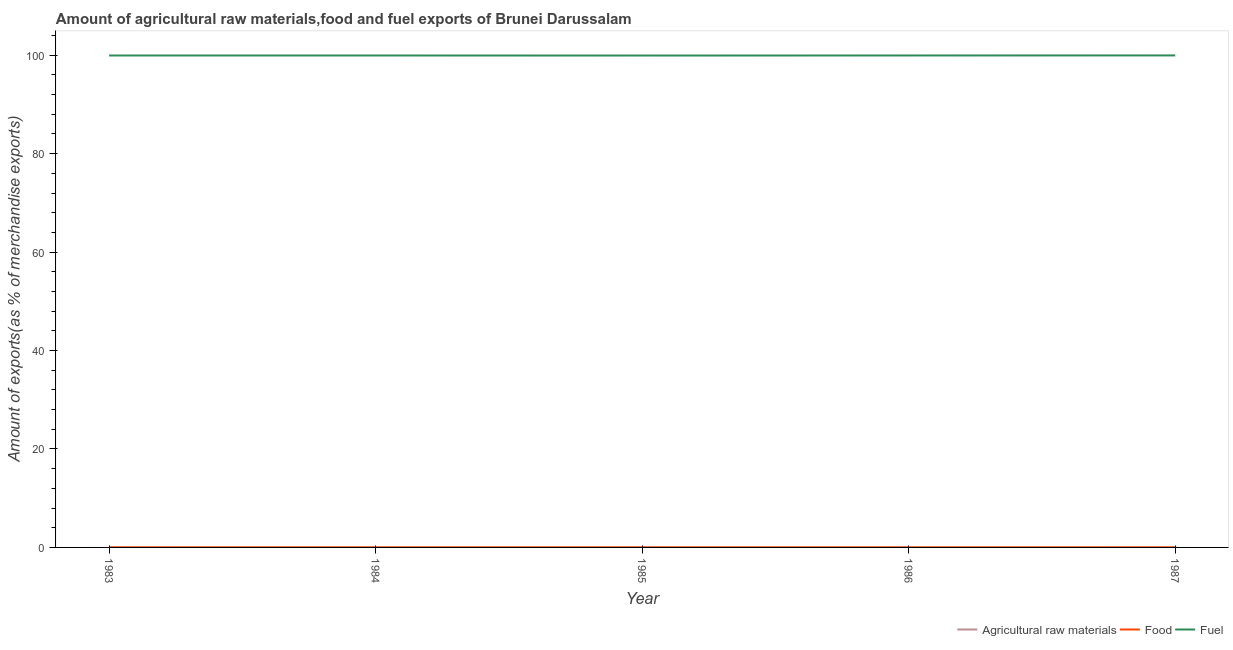How many different coloured lines are there?
Ensure brevity in your answer.  3. What is the percentage of fuel exports in 1985?
Your answer should be very brief. 99.93. Across all years, what is the maximum percentage of fuel exports?
Your response must be concise. 99.95. Across all years, what is the minimum percentage of raw materials exports?
Your answer should be compact. 0. In which year was the percentage of food exports minimum?
Offer a very short reply. 1987. What is the total percentage of raw materials exports in the graph?
Give a very brief answer. 0.01. What is the difference between the percentage of raw materials exports in 1984 and that in 1985?
Provide a succinct answer. -0. What is the difference between the percentage of fuel exports in 1983 and the percentage of food exports in 1987?
Make the answer very short. 99.94. What is the average percentage of food exports per year?
Provide a succinct answer. 0.01. In the year 1987, what is the difference between the percentage of raw materials exports and percentage of fuel exports?
Make the answer very short. -99.95. What is the ratio of the percentage of food exports in 1983 to that in 1984?
Your answer should be very brief. 0.78. What is the difference between the highest and the second highest percentage of food exports?
Your answer should be very brief. 0. What is the difference between the highest and the lowest percentage of raw materials exports?
Make the answer very short. 0.01. Does the percentage of raw materials exports monotonically increase over the years?
Offer a very short reply. No. What is the difference between two consecutive major ticks on the Y-axis?
Offer a very short reply. 20. Are the values on the major ticks of Y-axis written in scientific E-notation?
Make the answer very short. No. Does the graph contain grids?
Your response must be concise. No. What is the title of the graph?
Keep it short and to the point. Amount of agricultural raw materials,food and fuel exports of Brunei Darussalam. What is the label or title of the Y-axis?
Ensure brevity in your answer.  Amount of exports(as % of merchandise exports). What is the Amount of exports(as % of merchandise exports) in Agricultural raw materials in 1983?
Make the answer very short. 0. What is the Amount of exports(as % of merchandise exports) in Food in 1983?
Give a very brief answer. 0.01. What is the Amount of exports(as % of merchandise exports) of Fuel in 1983?
Your response must be concise. 99.94. What is the Amount of exports(as % of merchandise exports) in Agricultural raw materials in 1984?
Provide a short and direct response. 0. What is the Amount of exports(as % of merchandise exports) of Food in 1984?
Your response must be concise. 0.01. What is the Amount of exports(as % of merchandise exports) in Fuel in 1984?
Provide a succinct answer. 99.94. What is the Amount of exports(as % of merchandise exports) of Agricultural raw materials in 1985?
Your answer should be compact. 0. What is the Amount of exports(as % of merchandise exports) of Food in 1985?
Ensure brevity in your answer.  0.01. What is the Amount of exports(as % of merchandise exports) in Fuel in 1985?
Keep it short and to the point. 99.93. What is the Amount of exports(as % of merchandise exports) in Agricultural raw materials in 1986?
Provide a short and direct response. 0. What is the Amount of exports(as % of merchandise exports) in Food in 1986?
Keep it short and to the point. 0.01. What is the Amount of exports(as % of merchandise exports) of Fuel in 1986?
Give a very brief answer. 99.95. What is the Amount of exports(as % of merchandise exports) in Agricultural raw materials in 1987?
Give a very brief answer. 0.01. What is the Amount of exports(as % of merchandise exports) in Food in 1987?
Offer a terse response. 0. What is the Amount of exports(as % of merchandise exports) of Fuel in 1987?
Make the answer very short. 99.95. Across all years, what is the maximum Amount of exports(as % of merchandise exports) of Agricultural raw materials?
Offer a very short reply. 0.01. Across all years, what is the maximum Amount of exports(as % of merchandise exports) of Food?
Your answer should be very brief. 0.01. Across all years, what is the maximum Amount of exports(as % of merchandise exports) of Fuel?
Ensure brevity in your answer.  99.95. Across all years, what is the minimum Amount of exports(as % of merchandise exports) in Agricultural raw materials?
Ensure brevity in your answer.  0. Across all years, what is the minimum Amount of exports(as % of merchandise exports) in Food?
Ensure brevity in your answer.  0. Across all years, what is the minimum Amount of exports(as % of merchandise exports) in Fuel?
Keep it short and to the point. 99.93. What is the total Amount of exports(as % of merchandise exports) of Agricultural raw materials in the graph?
Your answer should be compact. 0.01. What is the total Amount of exports(as % of merchandise exports) in Food in the graph?
Your response must be concise. 0.03. What is the total Amount of exports(as % of merchandise exports) of Fuel in the graph?
Make the answer very short. 499.72. What is the difference between the Amount of exports(as % of merchandise exports) of Agricultural raw materials in 1983 and that in 1984?
Keep it short and to the point. 0. What is the difference between the Amount of exports(as % of merchandise exports) in Food in 1983 and that in 1984?
Give a very brief answer. -0. What is the difference between the Amount of exports(as % of merchandise exports) of Agricultural raw materials in 1983 and that in 1985?
Provide a short and direct response. 0. What is the difference between the Amount of exports(as % of merchandise exports) in Food in 1983 and that in 1985?
Offer a terse response. -0. What is the difference between the Amount of exports(as % of merchandise exports) in Fuel in 1983 and that in 1985?
Ensure brevity in your answer.  0.01. What is the difference between the Amount of exports(as % of merchandise exports) of Agricultural raw materials in 1983 and that in 1986?
Your answer should be compact. 0. What is the difference between the Amount of exports(as % of merchandise exports) in Food in 1983 and that in 1986?
Your response must be concise. -0. What is the difference between the Amount of exports(as % of merchandise exports) of Fuel in 1983 and that in 1986?
Ensure brevity in your answer.  -0. What is the difference between the Amount of exports(as % of merchandise exports) in Agricultural raw materials in 1983 and that in 1987?
Give a very brief answer. -0. What is the difference between the Amount of exports(as % of merchandise exports) of Food in 1983 and that in 1987?
Provide a succinct answer. 0. What is the difference between the Amount of exports(as % of merchandise exports) of Fuel in 1983 and that in 1987?
Provide a succinct answer. -0.01. What is the difference between the Amount of exports(as % of merchandise exports) in Agricultural raw materials in 1984 and that in 1985?
Your answer should be very brief. -0. What is the difference between the Amount of exports(as % of merchandise exports) of Food in 1984 and that in 1985?
Provide a short and direct response. 0. What is the difference between the Amount of exports(as % of merchandise exports) in Fuel in 1984 and that in 1985?
Ensure brevity in your answer.  0.01. What is the difference between the Amount of exports(as % of merchandise exports) of Agricultural raw materials in 1984 and that in 1986?
Give a very brief answer. -0. What is the difference between the Amount of exports(as % of merchandise exports) in Food in 1984 and that in 1986?
Your answer should be very brief. 0. What is the difference between the Amount of exports(as % of merchandise exports) in Fuel in 1984 and that in 1986?
Your answer should be very brief. -0. What is the difference between the Amount of exports(as % of merchandise exports) of Agricultural raw materials in 1984 and that in 1987?
Provide a short and direct response. -0.01. What is the difference between the Amount of exports(as % of merchandise exports) of Food in 1984 and that in 1987?
Your response must be concise. 0. What is the difference between the Amount of exports(as % of merchandise exports) of Fuel in 1984 and that in 1987?
Offer a very short reply. -0.01. What is the difference between the Amount of exports(as % of merchandise exports) of Fuel in 1985 and that in 1986?
Provide a succinct answer. -0.01. What is the difference between the Amount of exports(as % of merchandise exports) of Agricultural raw materials in 1985 and that in 1987?
Provide a short and direct response. -0.01. What is the difference between the Amount of exports(as % of merchandise exports) of Food in 1985 and that in 1987?
Your answer should be very brief. 0. What is the difference between the Amount of exports(as % of merchandise exports) of Fuel in 1985 and that in 1987?
Give a very brief answer. -0.02. What is the difference between the Amount of exports(as % of merchandise exports) of Agricultural raw materials in 1986 and that in 1987?
Your answer should be very brief. -0.01. What is the difference between the Amount of exports(as % of merchandise exports) in Food in 1986 and that in 1987?
Keep it short and to the point. 0. What is the difference between the Amount of exports(as % of merchandise exports) in Fuel in 1986 and that in 1987?
Your answer should be very brief. -0.01. What is the difference between the Amount of exports(as % of merchandise exports) of Agricultural raw materials in 1983 and the Amount of exports(as % of merchandise exports) of Food in 1984?
Offer a very short reply. -0. What is the difference between the Amount of exports(as % of merchandise exports) in Agricultural raw materials in 1983 and the Amount of exports(as % of merchandise exports) in Fuel in 1984?
Provide a short and direct response. -99.94. What is the difference between the Amount of exports(as % of merchandise exports) of Food in 1983 and the Amount of exports(as % of merchandise exports) of Fuel in 1984?
Your response must be concise. -99.94. What is the difference between the Amount of exports(as % of merchandise exports) in Agricultural raw materials in 1983 and the Amount of exports(as % of merchandise exports) in Food in 1985?
Provide a short and direct response. -0. What is the difference between the Amount of exports(as % of merchandise exports) of Agricultural raw materials in 1983 and the Amount of exports(as % of merchandise exports) of Fuel in 1985?
Your response must be concise. -99.93. What is the difference between the Amount of exports(as % of merchandise exports) of Food in 1983 and the Amount of exports(as % of merchandise exports) of Fuel in 1985?
Provide a succinct answer. -99.93. What is the difference between the Amount of exports(as % of merchandise exports) of Agricultural raw materials in 1983 and the Amount of exports(as % of merchandise exports) of Food in 1986?
Give a very brief answer. -0. What is the difference between the Amount of exports(as % of merchandise exports) in Agricultural raw materials in 1983 and the Amount of exports(as % of merchandise exports) in Fuel in 1986?
Offer a terse response. -99.94. What is the difference between the Amount of exports(as % of merchandise exports) in Food in 1983 and the Amount of exports(as % of merchandise exports) in Fuel in 1986?
Give a very brief answer. -99.94. What is the difference between the Amount of exports(as % of merchandise exports) in Agricultural raw materials in 1983 and the Amount of exports(as % of merchandise exports) in Food in 1987?
Your answer should be very brief. 0. What is the difference between the Amount of exports(as % of merchandise exports) in Agricultural raw materials in 1983 and the Amount of exports(as % of merchandise exports) in Fuel in 1987?
Give a very brief answer. -99.95. What is the difference between the Amount of exports(as % of merchandise exports) of Food in 1983 and the Amount of exports(as % of merchandise exports) of Fuel in 1987?
Offer a very short reply. -99.95. What is the difference between the Amount of exports(as % of merchandise exports) of Agricultural raw materials in 1984 and the Amount of exports(as % of merchandise exports) of Food in 1985?
Keep it short and to the point. -0.01. What is the difference between the Amount of exports(as % of merchandise exports) in Agricultural raw materials in 1984 and the Amount of exports(as % of merchandise exports) in Fuel in 1985?
Your answer should be compact. -99.93. What is the difference between the Amount of exports(as % of merchandise exports) in Food in 1984 and the Amount of exports(as % of merchandise exports) in Fuel in 1985?
Your answer should be very brief. -99.93. What is the difference between the Amount of exports(as % of merchandise exports) of Agricultural raw materials in 1984 and the Amount of exports(as % of merchandise exports) of Food in 1986?
Your response must be concise. -0.01. What is the difference between the Amount of exports(as % of merchandise exports) in Agricultural raw materials in 1984 and the Amount of exports(as % of merchandise exports) in Fuel in 1986?
Make the answer very short. -99.95. What is the difference between the Amount of exports(as % of merchandise exports) in Food in 1984 and the Amount of exports(as % of merchandise exports) in Fuel in 1986?
Provide a short and direct response. -99.94. What is the difference between the Amount of exports(as % of merchandise exports) in Agricultural raw materials in 1984 and the Amount of exports(as % of merchandise exports) in Food in 1987?
Your answer should be compact. -0. What is the difference between the Amount of exports(as % of merchandise exports) in Agricultural raw materials in 1984 and the Amount of exports(as % of merchandise exports) in Fuel in 1987?
Your answer should be compact. -99.95. What is the difference between the Amount of exports(as % of merchandise exports) in Food in 1984 and the Amount of exports(as % of merchandise exports) in Fuel in 1987?
Ensure brevity in your answer.  -99.95. What is the difference between the Amount of exports(as % of merchandise exports) of Agricultural raw materials in 1985 and the Amount of exports(as % of merchandise exports) of Food in 1986?
Ensure brevity in your answer.  -0.01. What is the difference between the Amount of exports(as % of merchandise exports) of Agricultural raw materials in 1985 and the Amount of exports(as % of merchandise exports) of Fuel in 1986?
Offer a very short reply. -99.95. What is the difference between the Amount of exports(as % of merchandise exports) of Food in 1985 and the Amount of exports(as % of merchandise exports) of Fuel in 1986?
Offer a terse response. -99.94. What is the difference between the Amount of exports(as % of merchandise exports) in Agricultural raw materials in 1985 and the Amount of exports(as % of merchandise exports) in Food in 1987?
Ensure brevity in your answer.  -0. What is the difference between the Amount of exports(as % of merchandise exports) of Agricultural raw materials in 1985 and the Amount of exports(as % of merchandise exports) of Fuel in 1987?
Your answer should be compact. -99.95. What is the difference between the Amount of exports(as % of merchandise exports) of Food in 1985 and the Amount of exports(as % of merchandise exports) of Fuel in 1987?
Ensure brevity in your answer.  -99.95. What is the difference between the Amount of exports(as % of merchandise exports) of Agricultural raw materials in 1986 and the Amount of exports(as % of merchandise exports) of Food in 1987?
Your answer should be very brief. -0. What is the difference between the Amount of exports(as % of merchandise exports) in Agricultural raw materials in 1986 and the Amount of exports(as % of merchandise exports) in Fuel in 1987?
Give a very brief answer. -99.95. What is the difference between the Amount of exports(as % of merchandise exports) in Food in 1986 and the Amount of exports(as % of merchandise exports) in Fuel in 1987?
Ensure brevity in your answer.  -99.95. What is the average Amount of exports(as % of merchandise exports) of Agricultural raw materials per year?
Provide a short and direct response. 0. What is the average Amount of exports(as % of merchandise exports) in Food per year?
Keep it short and to the point. 0.01. What is the average Amount of exports(as % of merchandise exports) of Fuel per year?
Give a very brief answer. 99.94. In the year 1983, what is the difference between the Amount of exports(as % of merchandise exports) in Agricultural raw materials and Amount of exports(as % of merchandise exports) in Food?
Your response must be concise. -0. In the year 1983, what is the difference between the Amount of exports(as % of merchandise exports) in Agricultural raw materials and Amount of exports(as % of merchandise exports) in Fuel?
Your answer should be compact. -99.94. In the year 1983, what is the difference between the Amount of exports(as % of merchandise exports) in Food and Amount of exports(as % of merchandise exports) in Fuel?
Your answer should be compact. -99.94. In the year 1984, what is the difference between the Amount of exports(as % of merchandise exports) in Agricultural raw materials and Amount of exports(as % of merchandise exports) in Food?
Make the answer very short. -0.01. In the year 1984, what is the difference between the Amount of exports(as % of merchandise exports) of Agricultural raw materials and Amount of exports(as % of merchandise exports) of Fuel?
Make the answer very short. -99.94. In the year 1984, what is the difference between the Amount of exports(as % of merchandise exports) in Food and Amount of exports(as % of merchandise exports) in Fuel?
Your response must be concise. -99.94. In the year 1985, what is the difference between the Amount of exports(as % of merchandise exports) in Agricultural raw materials and Amount of exports(as % of merchandise exports) in Food?
Provide a succinct answer. -0.01. In the year 1985, what is the difference between the Amount of exports(as % of merchandise exports) of Agricultural raw materials and Amount of exports(as % of merchandise exports) of Fuel?
Keep it short and to the point. -99.93. In the year 1985, what is the difference between the Amount of exports(as % of merchandise exports) in Food and Amount of exports(as % of merchandise exports) in Fuel?
Ensure brevity in your answer.  -99.93. In the year 1986, what is the difference between the Amount of exports(as % of merchandise exports) in Agricultural raw materials and Amount of exports(as % of merchandise exports) in Food?
Your answer should be compact. -0.01. In the year 1986, what is the difference between the Amount of exports(as % of merchandise exports) of Agricultural raw materials and Amount of exports(as % of merchandise exports) of Fuel?
Give a very brief answer. -99.95. In the year 1986, what is the difference between the Amount of exports(as % of merchandise exports) of Food and Amount of exports(as % of merchandise exports) of Fuel?
Provide a short and direct response. -99.94. In the year 1987, what is the difference between the Amount of exports(as % of merchandise exports) of Agricultural raw materials and Amount of exports(as % of merchandise exports) of Food?
Give a very brief answer. 0. In the year 1987, what is the difference between the Amount of exports(as % of merchandise exports) of Agricultural raw materials and Amount of exports(as % of merchandise exports) of Fuel?
Your answer should be very brief. -99.95. In the year 1987, what is the difference between the Amount of exports(as % of merchandise exports) of Food and Amount of exports(as % of merchandise exports) of Fuel?
Your answer should be very brief. -99.95. What is the ratio of the Amount of exports(as % of merchandise exports) of Agricultural raw materials in 1983 to that in 1984?
Provide a short and direct response. 4.48. What is the ratio of the Amount of exports(as % of merchandise exports) in Food in 1983 to that in 1984?
Your answer should be very brief. 0.78. What is the ratio of the Amount of exports(as % of merchandise exports) in Fuel in 1983 to that in 1984?
Provide a succinct answer. 1. What is the ratio of the Amount of exports(as % of merchandise exports) of Agricultural raw materials in 1983 to that in 1985?
Your answer should be very brief. 3.53. What is the ratio of the Amount of exports(as % of merchandise exports) of Food in 1983 to that in 1985?
Give a very brief answer. 0.82. What is the ratio of the Amount of exports(as % of merchandise exports) in Fuel in 1983 to that in 1985?
Your answer should be very brief. 1. What is the ratio of the Amount of exports(as % of merchandise exports) in Agricultural raw materials in 1983 to that in 1986?
Provide a short and direct response. 3.88. What is the ratio of the Amount of exports(as % of merchandise exports) of Food in 1983 to that in 1986?
Offer a terse response. 0.86. What is the ratio of the Amount of exports(as % of merchandise exports) of Agricultural raw materials in 1983 to that in 1987?
Ensure brevity in your answer.  0.57. What is the ratio of the Amount of exports(as % of merchandise exports) in Food in 1983 to that in 1987?
Ensure brevity in your answer.  1.45. What is the ratio of the Amount of exports(as % of merchandise exports) in Fuel in 1983 to that in 1987?
Give a very brief answer. 1. What is the ratio of the Amount of exports(as % of merchandise exports) of Agricultural raw materials in 1984 to that in 1985?
Offer a very short reply. 0.79. What is the ratio of the Amount of exports(as % of merchandise exports) of Food in 1984 to that in 1985?
Keep it short and to the point. 1.05. What is the ratio of the Amount of exports(as % of merchandise exports) of Fuel in 1984 to that in 1985?
Give a very brief answer. 1. What is the ratio of the Amount of exports(as % of merchandise exports) in Agricultural raw materials in 1984 to that in 1986?
Provide a succinct answer. 0.87. What is the ratio of the Amount of exports(as % of merchandise exports) of Food in 1984 to that in 1986?
Your response must be concise. 1.1. What is the ratio of the Amount of exports(as % of merchandise exports) in Fuel in 1984 to that in 1986?
Offer a terse response. 1. What is the ratio of the Amount of exports(as % of merchandise exports) in Agricultural raw materials in 1984 to that in 1987?
Provide a succinct answer. 0.13. What is the ratio of the Amount of exports(as % of merchandise exports) of Food in 1984 to that in 1987?
Give a very brief answer. 1.86. What is the ratio of the Amount of exports(as % of merchandise exports) in Agricultural raw materials in 1985 to that in 1986?
Give a very brief answer. 1.1. What is the ratio of the Amount of exports(as % of merchandise exports) in Food in 1985 to that in 1986?
Offer a terse response. 1.04. What is the ratio of the Amount of exports(as % of merchandise exports) of Agricultural raw materials in 1985 to that in 1987?
Provide a succinct answer. 0.16. What is the ratio of the Amount of exports(as % of merchandise exports) in Food in 1985 to that in 1987?
Ensure brevity in your answer.  1.77. What is the ratio of the Amount of exports(as % of merchandise exports) of Agricultural raw materials in 1986 to that in 1987?
Keep it short and to the point. 0.15. What is the ratio of the Amount of exports(as % of merchandise exports) of Food in 1986 to that in 1987?
Your answer should be compact. 1.69. What is the ratio of the Amount of exports(as % of merchandise exports) in Fuel in 1986 to that in 1987?
Offer a very short reply. 1. What is the difference between the highest and the second highest Amount of exports(as % of merchandise exports) of Agricultural raw materials?
Offer a very short reply. 0. What is the difference between the highest and the second highest Amount of exports(as % of merchandise exports) in Fuel?
Your response must be concise. 0.01. What is the difference between the highest and the lowest Amount of exports(as % of merchandise exports) of Agricultural raw materials?
Give a very brief answer. 0.01. What is the difference between the highest and the lowest Amount of exports(as % of merchandise exports) in Food?
Provide a succinct answer. 0. What is the difference between the highest and the lowest Amount of exports(as % of merchandise exports) of Fuel?
Your answer should be very brief. 0.02. 